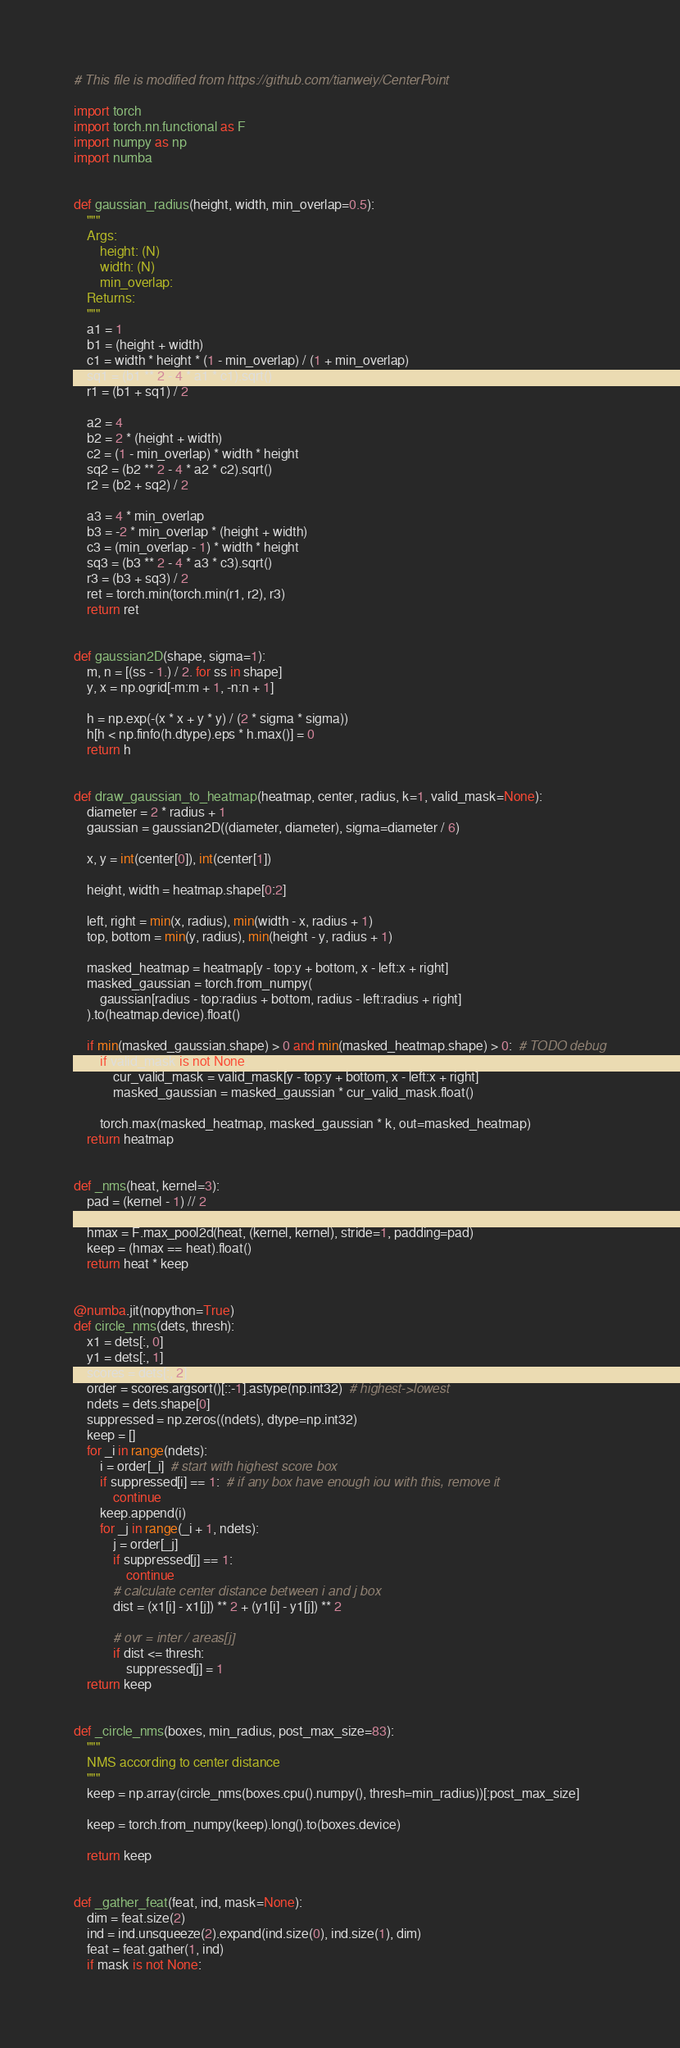Convert code to text. <code><loc_0><loc_0><loc_500><loc_500><_Python_># This file is modified from https://github.com/tianweiy/CenterPoint

import torch
import torch.nn.functional as F
import numpy as np
import numba


def gaussian_radius(height, width, min_overlap=0.5):
    """
    Args:
        height: (N)
        width: (N)
        min_overlap:
    Returns:
    """
    a1 = 1
    b1 = (height + width)
    c1 = width * height * (1 - min_overlap) / (1 + min_overlap)
    sq1 = (b1 ** 2 - 4 * a1 * c1).sqrt()
    r1 = (b1 + sq1) / 2

    a2 = 4
    b2 = 2 * (height + width)
    c2 = (1 - min_overlap) * width * height
    sq2 = (b2 ** 2 - 4 * a2 * c2).sqrt()
    r2 = (b2 + sq2) / 2

    a3 = 4 * min_overlap
    b3 = -2 * min_overlap * (height + width)
    c3 = (min_overlap - 1) * width * height
    sq3 = (b3 ** 2 - 4 * a3 * c3).sqrt()
    r3 = (b3 + sq3) / 2
    ret = torch.min(torch.min(r1, r2), r3)
    return ret


def gaussian2D(shape, sigma=1):
    m, n = [(ss - 1.) / 2. for ss in shape]
    y, x = np.ogrid[-m:m + 1, -n:n + 1]

    h = np.exp(-(x * x + y * y) / (2 * sigma * sigma))
    h[h < np.finfo(h.dtype).eps * h.max()] = 0
    return h


def draw_gaussian_to_heatmap(heatmap, center, radius, k=1, valid_mask=None):
    diameter = 2 * radius + 1
    gaussian = gaussian2D((diameter, diameter), sigma=diameter / 6)

    x, y = int(center[0]), int(center[1])

    height, width = heatmap.shape[0:2]

    left, right = min(x, radius), min(width - x, radius + 1)
    top, bottom = min(y, radius), min(height - y, radius + 1)

    masked_heatmap = heatmap[y - top:y + bottom, x - left:x + right]
    masked_gaussian = torch.from_numpy(
        gaussian[radius - top:radius + bottom, radius - left:radius + right]
    ).to(heatmap.device).float()

    if min(masked_gaussian.shape) > 0 and min(masked_heatmap.shape) > 0:  # TODO debug
        if valid_mask is not None:
            cur_valid_mask = valid_mask[y - top:y + bottom, x - left:x + right]
            masked_gaussian = masked_gaussian * cur_valid_mask.float()

        torch.max(masked_heatmap, masked_gaussian * k, out=masked_heatmap)
    return heatmap


def _nms(heat, kernel=3):
    pad = (kernel - 1) // 2

    hmax = F.max_pool2d(heat, (kernel, kernel), stride=1, padding=pad)
    keep = (hmax == heat).float()
    return heat * keep


@numba.jit(nopython=True)
def circle_nms(dets, thresh):
    x1 = dets[:, 0]
    y1 = dets[:, 1]
    scores = dets[:, 2]
    order = scores.argsort()[::-1].astype(np.int32)  # highest->lowest
    ndets = dets.shape[0]
    suppressed = np.zeros((ndets), dtype=np.int32)
    keep = []
    for _i in range(ndets):
        i = order[_i]  # start with highest score box
        if suppressed[i] == 1:  # if any box have enough iou with this, remove it
            continue
        keep.append(i)
        for _j in range(_i + 1, ndets):
            j = order[_j]
            if suppressed[j] == 1:
                continue
            # calculate center distance between i and j box
            dist = (x1[i] - x1[j]) ** 2 + (y1[i] - y1[j]) ** 2

            # ovr = inter / areas[j]
            if dist <= thresh:
                suppressed[j] = 1
    return keep


def _circle_nms(boxes, min_radius, post_max_size=83):
    """
    NMS according to center distance
    """
    keep = np.array(circle_nms(boxes.cpu().numpy(), thresh=min_radius))[:post_max_size]

    keep = torch.from_numpy(keep).long().to(boxes.device)

    return keep


def _gather_feat(feat, ind, mask=None):
    dim = feat.size(2)
    ind = ind.unsqueeze(2).expand(ind.size(0), ind.size(1), dim)
    feat = feat.gather(1, ind)
    if mask is not None:</code> 